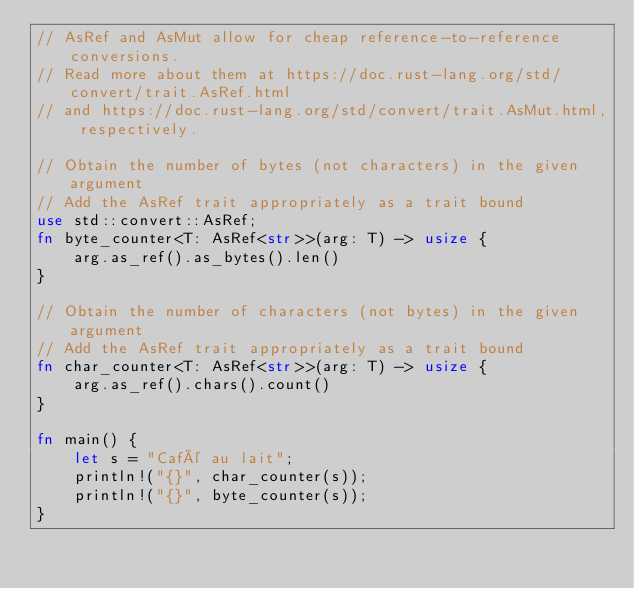Convert code to text. <code><loc_0><loc_0><loc_500><loc_500><_Rust_>// AsRef and AsMut allow for cheap reference-to-reference conversions.
// Read more about them at https://doc.rust-lang.org/std/convert/trait.AsRef.html
// and https://doc.rust-lang.org/std/convert/trait.AsMut.html, respectively.

// Obtain the number of bytes (not characters) in the given argument
// Add the AsRef trait appropriately as a trait bound
use std::convert::AsRef;
fn byte_counter<T: AsRef<str>>(arg: T) -> usize {
    arg.as_ref().as_bytes().len()
}

// Obtain the number of characters (not bytes) in the given argument
// Add the AsRef trait appropriately as a trait bound
fn char_counter<T: AsRef<str>>(arg: T) -> usize {
    arg.as_ref().chars().count()
}

fn main() {
    let s = "Café au lait";
    println!("{}", char_counter(s));
    println!("{}", byte_counter(s));
}
</code> 